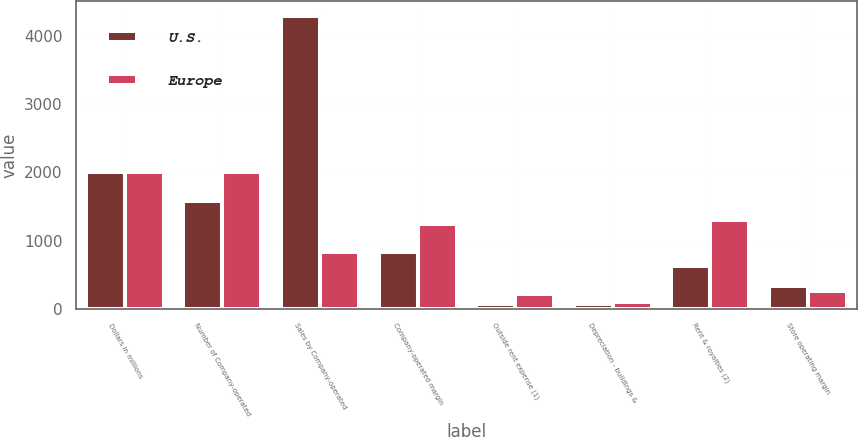<chart> <loc_0><loc_0><loc_500><loc_500><stacked_bar_chart><ecel><fcel>Dollars in millions<fcel>Number of Company-operated<fcel>Sales by Company-operated<fcel>Company-operated margin<fcel>Outside rent expense (1)<fcel>Depreciation - buildings &<fcel>Rent & royalties (2)<fcel>Store operating margin<nl><fcel>U.S.<fcel>2009<fcel>1578<fcel>4295<fcel>832<fcel>65<fcel>70<fcel>634<fcel>333<nl><fcel>Europe<fcel>2009<fcel>2001<fcel>832<fcel>1240<fcel>222<fcel>100<fcel>1306<fcel>256<nl></chart> 